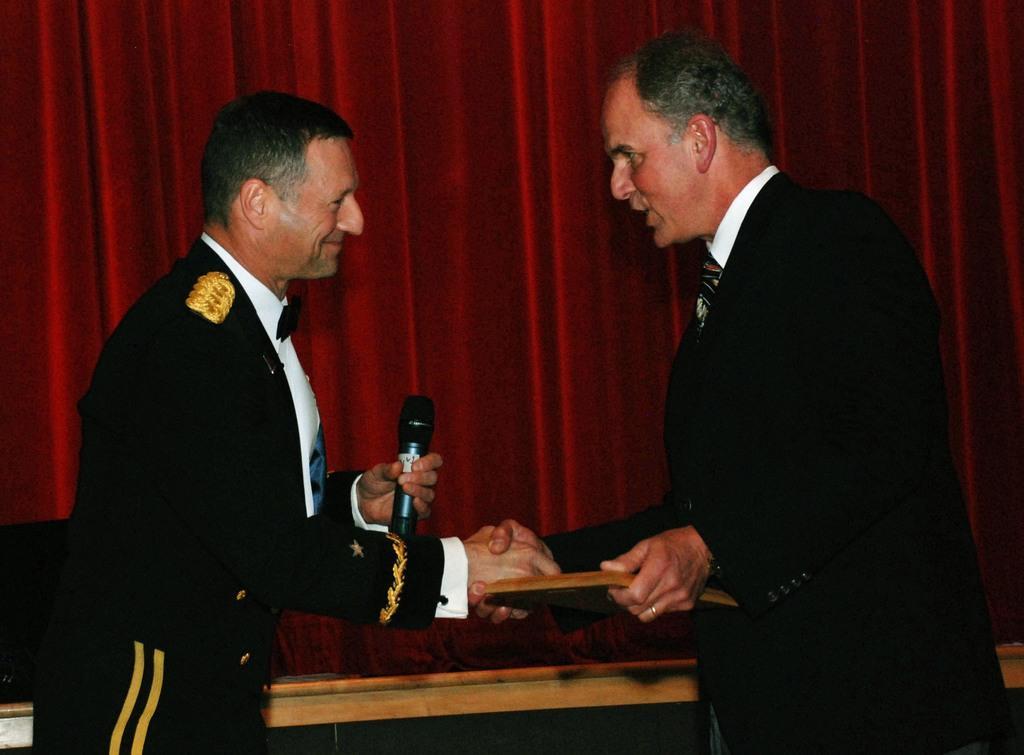Describe this image in one or two sentences. In this image, we can see two men standing and shaking hands, one man is holding a microphone. We can see a curtain in the background. 